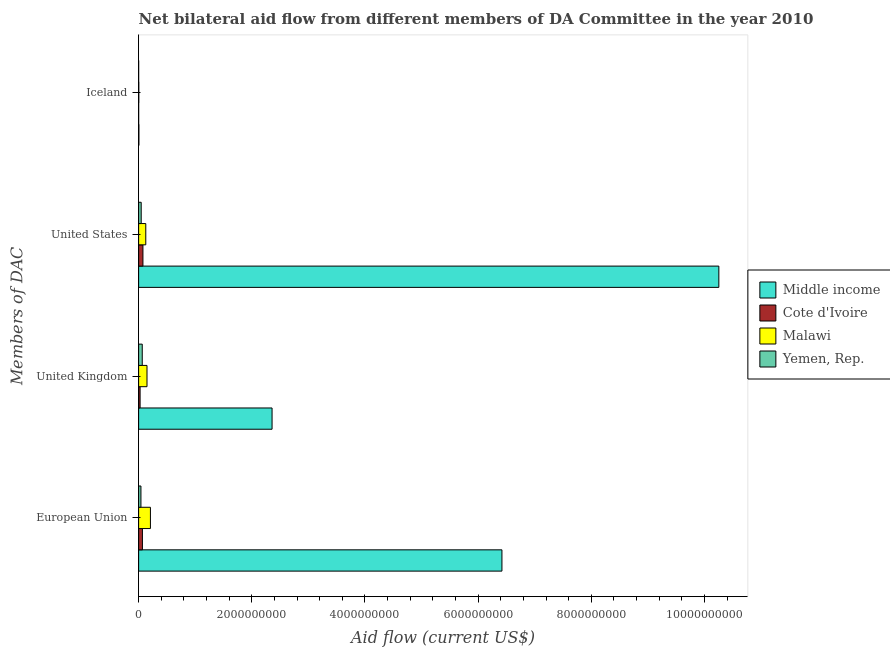What is the label of the 4th group of bars from the top?
Keep it short and to the point. European Union. What is the amount of aid given by us in Malawi?
Your response must be concise. 1.26e+08. Across all countries, what is the maximum amount of aid given by us?
Offer a very short reply. 1.03e+1. Across all countries, what is the minimum amount of aid given by eu?
Make the answer very short. 4.07e+07. In which country was the amount of aid given by iceland minimum?
Give a very brief answer. Yemen, Rep. What is the total amount of aid given by uk in the graph?
Give a very brief answer. 2.60e+09. What is the difference between the amount of aid given by iceland in Malawi and that in Middle income?
Ensure brevity in your answer.  -2.12e+06. What is the difference between the amount of aid given by eu in Cote d'Ivoire and the amount of aid given by iceland in Middle income?
Provide a short and direct response. 6.22e+07. What is the average amount of aid given by uk per country?
Keep it short and to the point. 6.49e+08. What is the difference between the amount of aid given by iceland and amount of aid given by uk in Yemen, Rep.?
Offer a very short reply. -6.38e+07. What is the ratio of the amount of aid given by us in Middle income to that in Malawi?
Offer a terse response. 81.19. Is the difference between the amount of aid given by iceland in Cote d'Ivoire and Middle income greater than the difference between the amount of aid given by us in Cote d'Ivoire and Middle income?
Provide a short and direct response. Yes. What is the difference between the highest and the second highest amount of aid given by eu?
Make the answer very short. 6.21e+09. What is the difference between the highest and the lowest amount of aid given by us?
Make the answer very short. 1.02e+1. Is the sum of the amount of aid given by iceland in Cote d'Ivoire and Malawi greater than the maximum amount of aid given by us across all countries?
Your answer should be compact. No. What does the 4th bar from the top in European Union represents?
Provide a succinct answer. Middle income. What does the 2nd bar from the bottom in European Union represents?
Keep it short and to the point. Cote d'Ivoire. How many countries are there in the graph?
Provide a short and direct response. 4. Are the values on the major ticks of X-axis written in scientific E-notation?
Keep it short and to the point. No. Does the graph contain any zero values?
Your answer should be very brief. No. Where does the legend appear in the graph?
Provide a succinct answer. Center right. How many legend labels are there?
Offer a very short reply. 4. What is the title of the graph?
Give a very brief answer. Net bilateral aid flow from different members of DA Committee in the year 2010. Does "Korea (Democratic)" appear as one of the legend labels in the graph?
Provide a short and direct response. No. What is the label or title of the X-axis?
Give a very brief answer. Aid flow (current US$). What is the label or title of the Y-axis?
Ensure brevity in your answer.  Members of DAC. What is the Aid flow (current US$) in Middle income in European Union?
Your answer should be very brief. 6.42e+09. What is the Aid flow (current US$) of Cote d'Ivoire in European Union?
Your response must be concise. 6.69e+07. What is the Aid flow (current US$) in Malawi in European Union?
Your answer should be very brief. 2.08e+08. What is the Aid flow (current US$) of Yemen, Rep. in European Union?
Ensure brevity in your answer.  4.07e+07. What is the Aid flow (current US$) of Middle income in United Kingdom?
Provide a succinct answer. 2.36e+09. What is the Aid flow (current US$) in Cote d'Ivoire in United Kingdom?
Make the answer very short. 2.60e+07. What is the Aid flow (current US$) in Malawi in United Kingdom?
Offer a terse response. 1.48e+08. What is the Aid flow (current US$) of Yemen, Rep. in United Kingdom?
Ensure brevity in your answer.  6.39e+07. What is the Aid flow (current US$) in Middle income in United States?
Your answer should be very brief. 1.03e+1. What is the Aid flow (current US$) of Cote d'Ivoire in United States?
Ensure brevity in your answer.  7.63e+07. What is the Aid flow (current US$) of Malawi in United States?
Your answer should be very brief. 1.26e+08. What is the Aid flow (current US$) of Yemen, Rep. in United States?
Your answer should be compact. 4.54e+07. What is the Aid flow (current US$) of Middle income in Iceland?
Offer a terse response. 4.75e+06. What is the Aid flow (current US$) in Malawi in Iceland?
Keep it short and to the point. 2.63e+06. What is the Aid flow (current US$) in Yemen, Rep. in Iceland?
Give a very brief answer. 7.00e+04. Across all Members of DAC, what is the maximum Aid flow (current US$) of Middle income?
Keep it short and to the point. 1.03e+1. Across all Members of DAC, what is the maximum Aid flow (current US$) of Cote d'Ivoire?
Make the answer very short. 7.63e+07. Across all Members of DAC, what is the maximum Aid flow (current US$) of Malawi?
Ensure brevity in your answer.  2.08e+08. Across all Members of DAC, what is the maximum Aid flow (current US$) of Yemen, Rep.?
Offer a terse response. 6.39e+07. Across all Members of DAC, what is the minimum Aid flow (current US$) of Middle income?
Make the answer very short. 4.75e+06. Across all Members of DAC, what is the minimum Aid flow (current US$) in Malawi?
Give a very brief answer. 2.63e+06. Across all Members of DAC, what is the minimum Aid flow (current US$) of Yemen, Rep.?
Keep it short and to the point. 7.00e+04. What is the total Aid flow (current US$) in Middle income in the graph?
Provide a succinct answer. 1.90e+1. What is the total Aid flow (current US$) in Cote d'Ivoire in the graph?
Make the answer very short. 1.69e+08. What is the total Aid flow (current US$) of Malawi in the graph?
Make the answer very short. 4.85e+08. What is the total Aid flow (current US$) in Yemen, Rep. in the graph?
Make the answer very short. 1.50e+08. What is the difference between the Aid flow (current US$) in Middle income in European Union and that in United Kingdom?
Keep it short and to the point. 4.06e+09. What is the difference between the Aid flow (current US$) in Cote d'Ivoire in European Union and that in United Kingdom?
Your answer should be compact. 4.10e+07. What is the difference between the Aid flow (current US$) of Malawi in European Union and that in United Kingdom?
Offer a very short reply. 6.03e+07. What is the difference between the Aid flow (current US$) in Yemen, Rep. in European Union and that in United Kingdom?
Give a very brief answer. -2.32e+07. What is the difference between the Aid flow (current US$) of Middle income in European Union and that in United States?
Give a very brief answer. -3.83e+09. What is the difference between the Aid flow (current US$) in Cote d'Ivoire in European Union and that in United States?
Your answer should be very brief. -9.34e+06. What is the difference between the Aid flow (current US$) of Malawi in European Union and that in United States?
Your answer should be very brief. 8.20e+07. What is the difference between the Aid flow (current US$) of Yemen, Rep. in European Union and that in United States?
Your answer should be compact. -4.68e+06. What is the difference between the Aid flow (current US$) in Middle income in European Union and that in Iceland?
Keep it short and to the point. 6.42e+09. What is the difference between the Aid flow (current US$) in Cote d'Ivoire in European Union and that in Iceland?
Offer a very short reply. 6.68e+07. What is the difference between the Aid flow (current US$) in Malawi in European Union and that in Iceland?
Your response must be concise. 2.06e+08. What is the difference between the Aid flow (current US$) in Yemen, Rep. in European Union and that in Iceland?
Provide a short and direct response. 4.07e+07. What is the difference between the Aid flow (current US$) of Middle income in United Kingdom and that in United States?
Provide a short and direct response. -7.90e+09. What is the difference between the Aid flow (current US$) in Cote d'Ivoire in United Kingdom and that in United States?
Provide a succinct answer. -5.03e+07. What is the difference between the Aid flow (current US$) in Malawi in United Kingdom and that in United States?
Give a very brief answer. 2.17e+07. What is the difference between the Aid flow (current US$) in Yemen, Rep. in United Kingdom and that in United States?
Offer a very short reply. 1.85e+07. What is the difference between the Aid flow (current US$) in Middle income in United Kingdom and that in Iceland?
Make the answer very short. 2.35e+09. What is the difference between the Aid flow (current US$) of Cote d'Ivoire in United Kingdom and that in Iceland?
Provide a short and direct response. 2.59e+07. What is the difference between the Aid flow (current US$) in Malawi in United Kingdom and that in Iceland?
Your answer should be compact. 1.45e+08. What is the difference between the Aid flow (current US$) in Yemen, Rep. in United Kingdom and that in Iceland?
Offer a very short reply. 6.38e+07. What is the difference between the Aid flow (current US$) in Middle income in United States and that in Iceland?
Offer a terse response. 1.02e+1. What is the difference between the Aid flow (current US$) in Cote d'Ivoire in United States and that in Iceland?
Provide a short and direct response. 7.62e+07. What is the difference between the Aid flow (current US$) of Malawi in United States and that in Iceland?
Your response must be concise. 1.24e+08. What is the difference between the Aid flow (current US$) in Yemen, Rep. in United States and that in Iceland?
Keep it short and to the point. 4.53e+07. What is the difference between the Aid flow (current US$) of Middle income in European Union and the Aid flow (current US$) of Cote d'Ivoire in United Kingdom?
Provide a short and direct response. 6.39e+09. What is the difference between the Aid flow (current US$) of Middle income in European Union and the Aid flow (current US$) of Malawi in United Kingdom?
Keep it short and to the point. 6.27e+09. What is the difference between the Aid flow (current US$) in Middle income in European Union and the Aid flow (current US$) in Yemen, Rep. in United Kingdom?
Keep it short and to the point. 6.36e+09. What is the difference between the Aid flow (current US$) of Cote d'Ivoire in European Union and the Aid flow (current US$) of Malawi in United Kingdom?
Your answer should be very brief. -8.11e+07. What is the difference between the Aid flow (current US$) in Cote d'Ivoire in European Union and the Aid flow (current US$) in Yemen, Rep. in United Kingdom?
Offer a terse response. 3.01e+06. What is the difference between the Aid flow (current US$) of Malawi in European Union and the Aid flow (current US$) of Yemen, Rep. in United Kingdom?
Offer a very short reply. 1.44e+08. What is the difference between the Aid flow (current US$) in Middle income in European Union and the Aid flow (current US$) in Cote d'Ivoire in United States?
Provide a short and direct response. 6.34e+09. What is the difference between the Aid flow (current US$) of Middle income in European Union and the Aid flow (current US$) of Malawi in United States?
Give a very brief answer. 6.29e+09. What is the difference between the Aid flow (current US$) of Middle income in European Union and the Aid flow (current US$) of Yemen, Rep. in United States?
Give a very brief answer. 6.37e+09. What is the difference between the Aid flow (current US$) in Cote d'Ivoire in European Union and the Aid flow (current US$) in Malawi in United States?
Provide a succinct answer. -5.94e+07. What is the difference between the Aid flow (current US$) of Cote d'Ivoire in European Union and the Aid flow (current US$) of Yemen, Rep. in United States?
Keep it short and to the point. 2.15e+07. What is the difference between the Aid flow (current US$) in Malawi in European Union and the Aid flow (current US$) in Yemen, Rep. in United States?
Keep it short and to the point. 1.63e+08. What is the difference between the Aid flow (current US$) of Middle income in European Union and the Aid flow (current US$) of Cote d'Ivoire in Iceland?
Your response must be concise. 6.42e+09. What is the difference between the Aid flow (current US$) of Middle income in European Union and the Aid flow (current US$) of Malawi in Iceland?
Provide a short and direct response. 6.42e+09. What is the difference between the Aid flow (current US$) of Middle income in European Union and the Aid flow (current US$) of Yemen, Rep. in Iceland?
Offer a very short reply. 6.42e+09. What is the difference between the Aid flow (current US$) in Cote d'Ivoire in European Union and the Aid flow (current US$) in Malawi in Iceland?
Make the answer very short. 6.43e+07. What is the difference between the Aid flow (current US$) in Cote d'Ivoire in European Union and the Aid flow (current US$) in Yemen, Rep. in Iceland?
Your answer should be compact. 6.69e+07. What is the difference between the Aid flow (current US$) of Malawi in European Union and the Aid flow (current US$) of Yemen, Rep. in Iceland?
Make the answer very short. 2.08e+08. What is the difference between the Aid flow (current US$) of Middle income in United Kingdom and the Aid flow (current US$) of Cote d'Ivoire in United States?
Provide a short and direct response. 2.28e+09. What is the difference between the Aid flow (current US$) in Middle income in United Kingdom and the Aid flow (current US$) in Malawi in United States?
Your answer should be very brief. 2.23e+09. What is the difference between the Aid flow (current US$) in Middle income in United Kingdom and the Aid flow (current US$) in Yemen, Rep. in United States?
Your answer should be compact. 2.31e+09. What is the difference between the Aid flow (current US$) of Cote d'Ivoire in United Kingdom and the Aid flow (current US$) of Malawi in United States?
Your response must be concise. -1.00e+08. What is the difference between the Aid flow (current US$) in Cote d'Ivoire in United Kingdom and the Aid flow (current US$) in Yemen, Rep. in United States?
Give a very brief answer. -1.94e+07. What is the difference between the Aid flow (current US$) in Malawi in United Kingdom and the Aid flow (current US$) in Yemen, Rep. in United States?
Provide a succinct answer. 1.03e+08. What is the difference between the Aid flow (current US$) in Middle income in United Kingdom and the Aid flow (current US$) in Cote d'Ivoire in Iceland?
Make the answer very short. 2.36e+09. What is the difference between the Aid flow (current US$) of Middle income in United Kingdom and the Aid flow (current US$) of Malawi in Iceland?
Offer a very short reply. 2.36e+09. What is the difference between the Aid flow (current US$) in Middle income in United Kingdom and the Aid flow (current US$) in Yemen, Rep. in Iceland?
Your response must be concise. 2.36e+09. What is the difference between the Aid flow (current US$) of Cote d'Ivoire in United Kingdom and the Aid flow (current US$) of Malawi in Iceland?
Keep it short and to the point. 2.33e+07. What is the difference between the Aid flow (current US$) of Cote d'Ivoire in United Kingdom and the Aid flow (current US$) of Yemen, Rep. in Iceland?
Provide a succinct answer. 2.59e+07. What is the difference between the Aid flow (current US$) in Malawi in United Kingdom and the Aid flow (current US$) in Yemen, Rep. in Iceland?
Offer a very short reply. 1.48e+08. What is the difference between the Aid flow (current US$) of Middle income in United States and the Aid flow (current US$) of Cote d'Ivoire in Iceland?
Provide a short and direct response. 1.03e+1. What is the difference between the Aid flow (current US$) in Middle income in United States and the Aid flow (current US$) in Malawi in Iceland?
Ensure brevity in your answer.  1.03e+1. What is the difference between the Aid flow (current US$) of Middle income in United States and the Aid flow (current US$) of Yemen, Rep. in Iceland?
Offer a terse response. 1.03e+1. What is the difference between the Aid flow (current US$) in Cote d'Ivoire in United States and the Aid flow (current US$) in Malawi in Iceland?
Your answer should be compact. 7.36e+07. What is the difference between the Aid flow (current US$) in Cote d'Ivoire in United States and the Aid flow (current US$) in Yemen, Rep. in Iceland?
Your response must be concise. 7.62e+07. What is the difference between the Aid flow (current US$) in Malawi in United States and the Aid flow (current US$) in Yemen, Rep. in Iceland?
Keep it short and to the point. 1.26e+08. What is the average Aid flow (current US$) in Middle income per Members of DAC?
Your answer should be compact. 4.76e+09. What is the average Aid flow (current US$) in Cote d'Ivoire per Members of DAC?
Make the answer very short. 4.23e+07. What is the average Aid flow (current US$) of Malawi per Members of DAC?
Offer a terse response. 1.21e+08. What is the average Aid flow (current US$) of Yemen, Rep. per Members of DAC?
Provide a short and direct response. 3.75e+07. What is the difference between the Aid flow (current US$) of Middle income and Aid flow (current US$) of Cote d'Ivoire in European Union?
Provide a succinct answer. 6.35e+09. What is the difference between the Aid flow (current US$) of Middle income and Aid flow (current US$) of Malawi in European Union?
Keep it short and to the point. 6.21e+09. What is the difference between the Aid flow (current US$) in Middle income and Aid flow (current US$) in Yemen, Rep. in European Union?
Ensure brevity in your answer.  6.38e+09. What is the difference between the Aid flow (current US$) in Cote d'Ivoire and Aid flow (current US$) in Malawi in European Union?
Your answer should be very brief. -1.41e+08. What is the difference between the Aid flow (current US$) of Cote d'Ivoire and Aid flow (current US$) of Yemen, Rep. in European Union?
Your response must be concise. 2.62e+07. What is the difference between the Aid flow (current US$) in Malawi and Aid flow (current US$) in Yemen, Rep. in European Union?
Provide a short and direct response. 1.68e+08. What is the difference between the Aid flow (current US$) of Middle income and Aid flow (current US$) of Cote d'Ivoire in United Kingdom?
Keep it short and to the point. 2.33e+09. What is the difference between the Aid flow (current US$) in Middle income and Aid flow (current US$) in Malawi in United Kingdom?
Offer a very short reply. 2.21e+09. What is the difference between the Aid flow (current US$) of Middle income and Aid flow (current US$) of Yemen, Rep. in United Kingdom?
Your response must be concise. 2.29e+09. What is the difference between the Aid flow (current US$) in Cote d'Ivoire and Aid flow (current US$) in Malawi in United Kingdom?
Offer a terse response. -1.22e+08. What is the difference between the Aid flow (current US$) of Cote d'Ivoire and Aid flow (current US$) of Yemen, Rep. in United Kingdom?
Your answer should be compact. -3.80e+07. What is the difference between the Aid flow (current US$) in Malawi and Aid flow (current US$) in Yemen, Rep. in United Kingdom?
Your answer should be very brief. 8.41e+07. What is the difference between the Aid flow (current US$) in Middle income and Aid flow (current US$) in Cote d'Ivoire in United States?
Make the answer very short. 1.02e+1. What is the difference between the Aid flow (current US$) of Middle income and Aid flow (current US$) of Malawi in United States?
Your answer should be very brief. 1.01e+1. What is the difference between the Aid flow (current US$) of Middle income and Aid flow (current US$) of Yemen, Rep. in United States?
Provide a succinct answer. 1.02e+1. What is the difference between the Aid flow (current US$) of Cote d'Ivoire and Aid flow (current US$) of Malawi in United States?
Your answer should be very brief. -5.00e+07. What is the difference between the Aid flow (current US$) in Cote d'Ivoire and Aid flow (current US$) in Yemen, Rep. in United States?
Ensure brevity in your answer.  3.09e+07. What is the difference between the Aid flow (current US$) in Malawi and Aid flow (current US$) in Yemen, Rep. in United States?
Your answer should be compact. 8.09e+07. What is the difference between the Aid flow (current US$) in Middle income and Aid flow (current US$) in Cote d'Ivoire in Iceland?
Make the answer very short. 4.66e+06. What is the difference between the Aid flow (current US$) in Middle income and Aid flow (current US$) in Malawi in Iceland?
Your answer should be very brief. 2.12e+06. What is the difference between the Aid flow (current US$) in Middle income and Aid flow (current US$) in Yemen, Rep. in Iceland?
Offer a very short reply. 4.68e+06. What is the difference between the Aid flow (current US$) in Cote d'Ivoire and Aid flow (current US$) in Malawi in Iceland?
Your answer should be compact. -2.54e+06. What is the difference between the Aid flow (current US$) in Cote d'Ivoire and Aid flow (current US$) in Yemen, Rep. in Iceland?
Ensure brevity in your answer.  2.00e+04. What is the difference between the Aid flow (current US$) in Malawi and Aid flow (current US$) in Yemen, Rep. in Iceland?
Make the answer very short. 2.56e+06. What is the ratio of the Aid flow (current US$) in Middle income in European Union to that in United Kingdom?
Your response must be concise. 2.72. What is the ratio of the Aid flow (current US$) of Cote d'Ivoire in European Union to that in United Kingdom?
Your response must be concise. 2.58. What is the ratio of the Aid flow (current US$) of Malawi in European Union to that in United Kingdom?
Give a very brief answer. 1.41. What is the ratio of the Aid flow (current US$) of Yemen, Rep. in European Union to that in United Kingdom?
Ensure brevity in your answer.  0.64. What is the ratio of the Aid flow (current US$) of Middle income in European Union to that in United States?
Give a very brief answer. 0.63. What is the ratio of the Aid flow (current US$) of Cote d'Ivoire in European Union to that in United States?
Provide a succinct answer. 0.88. What is the ratio of the Aid flow (current US$) of Malawi in European Union to that in United States?
Make the answer very short. 1.65. What is the ratio of the Aid flow (current US$) of Yemen, Rep. in European Union to that in United States?
Your answer should be very brief. 0.9. What is the ratio of the Aid flow (current US$) of Middle income in European Union to that in Iceland?
Offer a very short reply. 1351.66. What is the ratio of the Aid flow (current US$) of Cote d'Ivoire in European Union to that in Iceland?
Provide a short and direct response. 743.67. What is the ratio of the Aid flow (current US$) in Malawi in European Union to that in Iceland?
Give a very brief answer. 79.21. What is the ratio of the Aid flow (current US$) of Yemen, Rep. in European Union to that in Iceland?
Your answer should be very brief. 581.86. What is the ratio of the Aid flow (current US$) in Middle income in United Kingdom to that in United States?
Keep it short and to the point. 0.23. What is the ratio of the Aid flow (current US$) of Cote d'Ivoire in United Kingdom to that in United States?
Your response must be concise. 0.34. What is the ratio of the Aid flow (current US$) of Malawi in United Kingdom to that in United States?
Offer a terse response. 1.17. What is the ratio of the Aid flow (current US$) in Yemen, Rep. in United Kingdom to that in United States?
Your response must be concise. 1.41. What is the ratio of the Aid flow (current US$) in Middle income in United Kingdom to that in Iceland?
Give a very brief answer. 496.44. What is the ratio of the Aid flow (current US$) in Cote d'Ivoire in United Kingdom to that in Iceland?
Make the answer very short. 288.44. What is the ratio of the Aid flow (current US$) in Malawi in United Kingdom to that in Iceland?
Your answer should be very brief. 56.29. What is the ratio of the Aid flow (current US$) in Yemen, Rep. in United Kingdom to that in Iceland?
Your answer should be very brief. 913.14. What is the ratio of the Aid flow (current US$) in Middle income in United States to that in Iceland?
Your answer should be compact. 2158.59. What is the ratio of the Aid flow (current US$) of Cote d'Ivoire in United States to that in Iceland?
Give a very brief answer. 847.44. What is the ratio of the Aid flow (current US$) in Malawi in United States to that in Iceland?
Provide a succinct answer. 48.02. What is the ratio of the Aid flow (current US$) in Yemen, Rep. in United States to that in Iceland?
Ensure brevity in your answer.  648.71. What is the difference between the highest and the second highest Aid flow (current US$) of Middle income?
Keep it short and to the point. 3.83e+09. What is the difference between the highest and the second highest Aid flow (current US$) of Cote d'Ivoire?
Your answer should be very brief. 9.34e+06. What is the difference between the highest and the second highest Aid flow (current US$) of Malawi?
Keep it short and to the point. 6.03e+07. What is the difference between the highest and the second highest Aid flow (current US$) in Yemen, Rep.?
Offer a terse response. 1.85e+07. What is the difference between the highest and the lowest Aid flow (current US$) in Middle income?
Make the answer very short. 1.02e+1. What is the difference between the highest and the lowest Aid flow (current US$) in Cote d'Ivoire?
Provide a short and direct response. 7.62e+07. What is the difference between the highest and the lowest Aid flow (current US$) of Malawi?
Offer a very short reply. 2.06e+08. What is the difference between the highest and the lowest Aid flow (current US$) in Yemen, Rep.?
Your answer should be compact. 6.38e+07. 